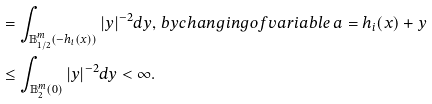<formula> <loc_0><loc_0><loc_500><loc_500>& = \int _ { \mathbb { B } _ { 1 / 2 } ^ { m } ( - h _ { i } ( x ) ) } | y | ^ { - 2 } d y , \, b y c h a n g i n g o f v a r i a b l e \, a = h _ { i } ( x ) + y \\ & \leq \int _ { \mathbb { B } _ { 2 } ^ { m } ( 0 ) } | y | ^ { - 2 } d y < \infty .</formula> 